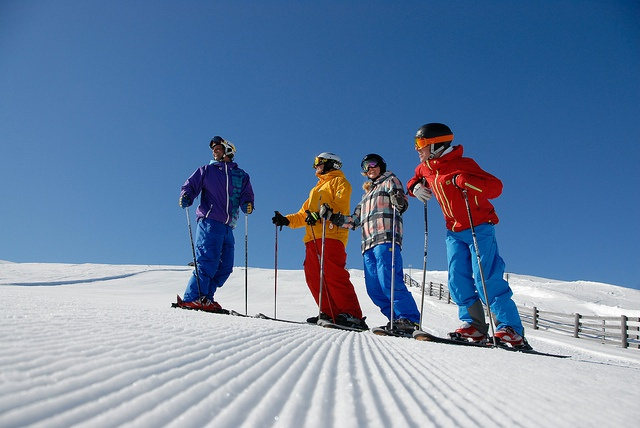Describe the objects in this image and their specific colors. I can see people in blue, maroon, and black tones, people in blue, navy, black, and gray tones, people in blue, black, navy, gray, and darkblue tones, people in blue, maroon, brown, and black tones, and snowboard in blue, black, gray, darkgray, and lightgray tones in this image. 